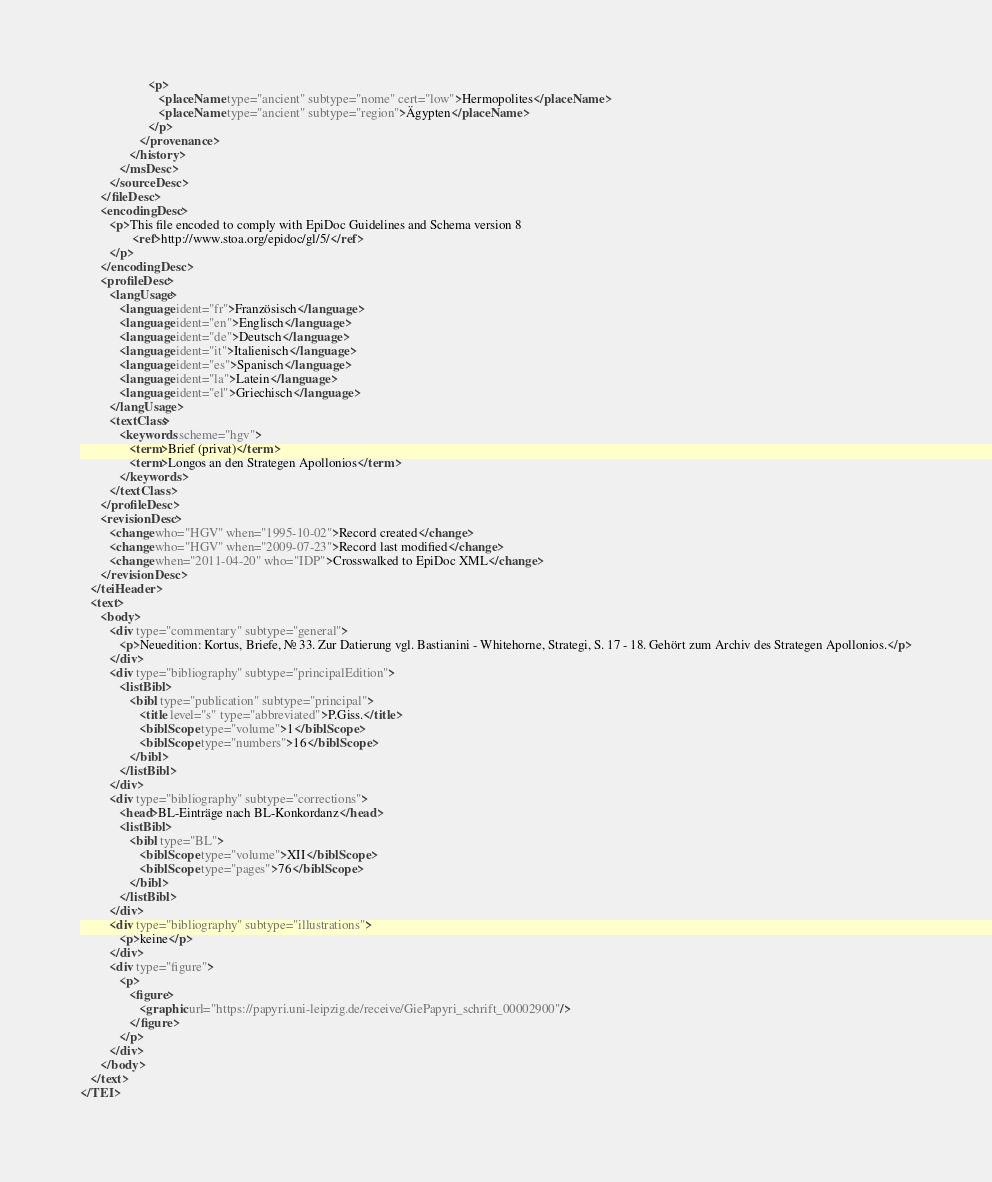<code> <loc_0><loc_0><loc_500><loc_500><_XML_>                     <p>
                        <placeName type="ancient" subtype="nome" cert="low">Hermopolites</placeName>
                        <placeName type="ancient" subtype="region">Ägypten</placeName>
                     </p>
                  </provenance>
               </history>
            </msDesc>
         </sourceDesc>
      </fileDesc>
      <encodingDesc>
         <p>This file encoded to comply with EpiDoc Guidelines and Schema version 8
                <ref>http://www.stoa.org/epidoc/gl/5/</ref>
         </p>
      </encodingDesc>
      <profileDesc>
         <langUsage>
            <language ident="fr">Französisch</language>
            <language ident="en">Englisch</language>
            <language ident="de">Deutsch</language>
            <language ident="it">Italienisch</language>
            <language ident="es">Spanisch</language>
            <language ident="la">Latein</language>
            <language ident="el">Griechisch</language>
         </langUsage>
         <textClass>
            <keywords scheme="hgv">
               <term>Brief (privat)</term>
               <term>Longos an den Strategen Apollonios</term>
            </keywords>
         </textClass>
      </profileDesc>
      <revisionDesc>
         <change who="HGV" when="1995-10-02">Record created</change>
         <change who="HGV" when="2009-07-23">Record last modified</change>
         <change when="2011-04-20" who="IDP">Crosswalked to EpiDoc XML</change>
      </revisionDesc>
   </teiHeader>
   <text>
      <body>
         <div type="commentary" subtype="general">
            <p>Neuedition: Kortus, Briefe, Nr. 33. Zur Datierung vgl. Bastianini - Whitehorne, Strategi, S. 17 - 18. Gehört zum Archiv des Strategen Apollonios.</p>
         </div>
         <div type="bibliography" subtype="principalEdition">
            <listBibl>
               <bibl type="publication" subtype="principal">
                  <title level="s" type="abbreviated">P.Giss.</title>
                  <biblScope type="volume">1</biblScope>
                  <biblScope type="numbers">16</biblScope>
               </bibl>
            </listBibl>
         </div>
         <div type="bibliography" subtype="corrections">
            <head>BL-Einträge nach BL-Konkordanz</head>
            <listBibl>
               <bibl type="BL">
                  <biblScope type="volume">XII</biblScope>
                  <biblScope type="pages">76</biblScope>
               </bibl>
            </listBibl>
         </div>
         <div type="bibliography" subtype="illustrations">
            <p>keine</p>
         </div>
         <div type="figure">
            <p>
               <figure>
                  <graphic url="https://papyri.uni-leipzig.de/receive/GiePapyri_schrift_00002900"/>
               </figure>
            </p>
         </div>
      </body>
   </text>
</TEI>
</code> 